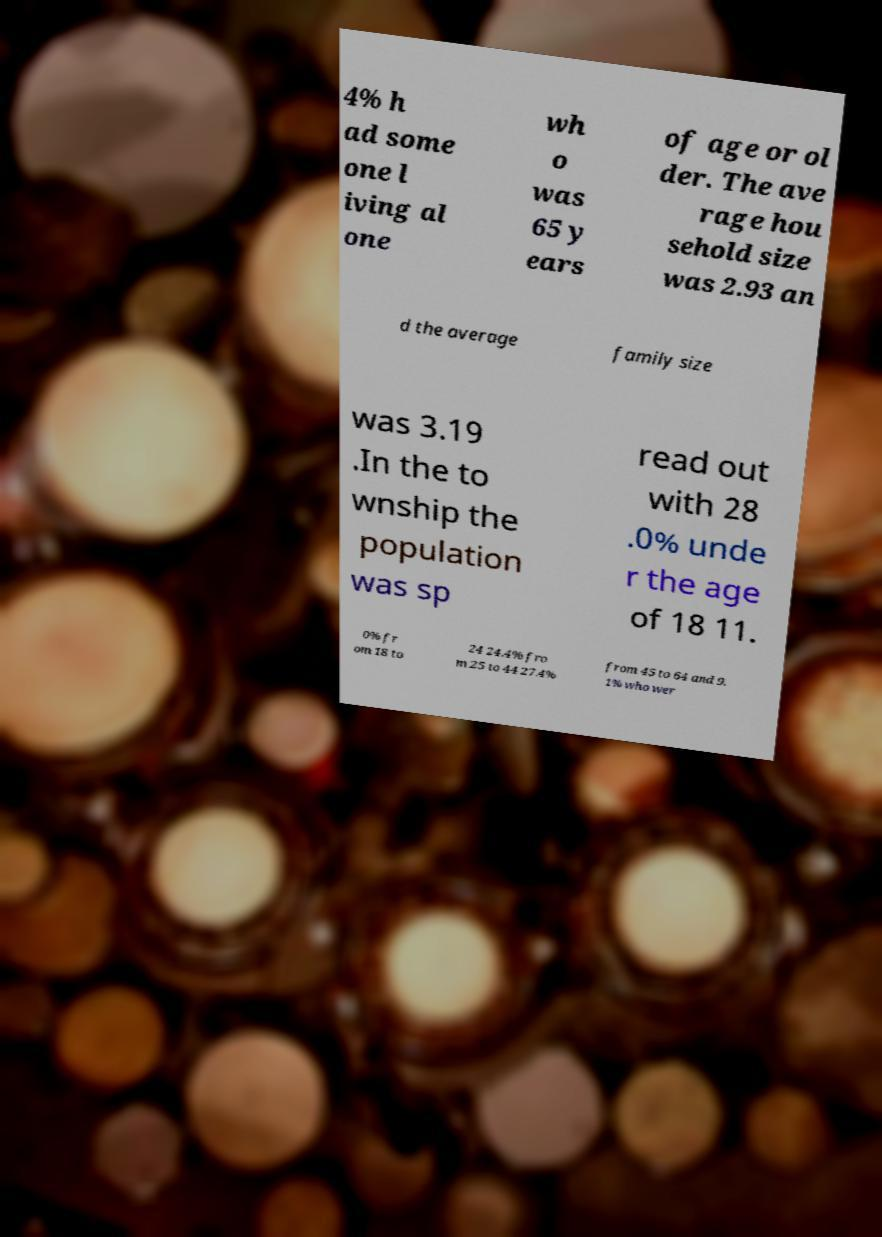Please read and relay the text visible in this image. What does it say? 4% h ad some one l iving al one wh o was 65 y ears of age or ol der. The ave rage hou sehold size was 2.93 an d the average family size was 3.19 .In the to wnship the population was sp read out with 28 .0% unde r the age of 18 11. 0% fr om 18 to 24 24.4% fro m 25 to 44 27.4% from 45 to 64 and 9. 1% who wer 